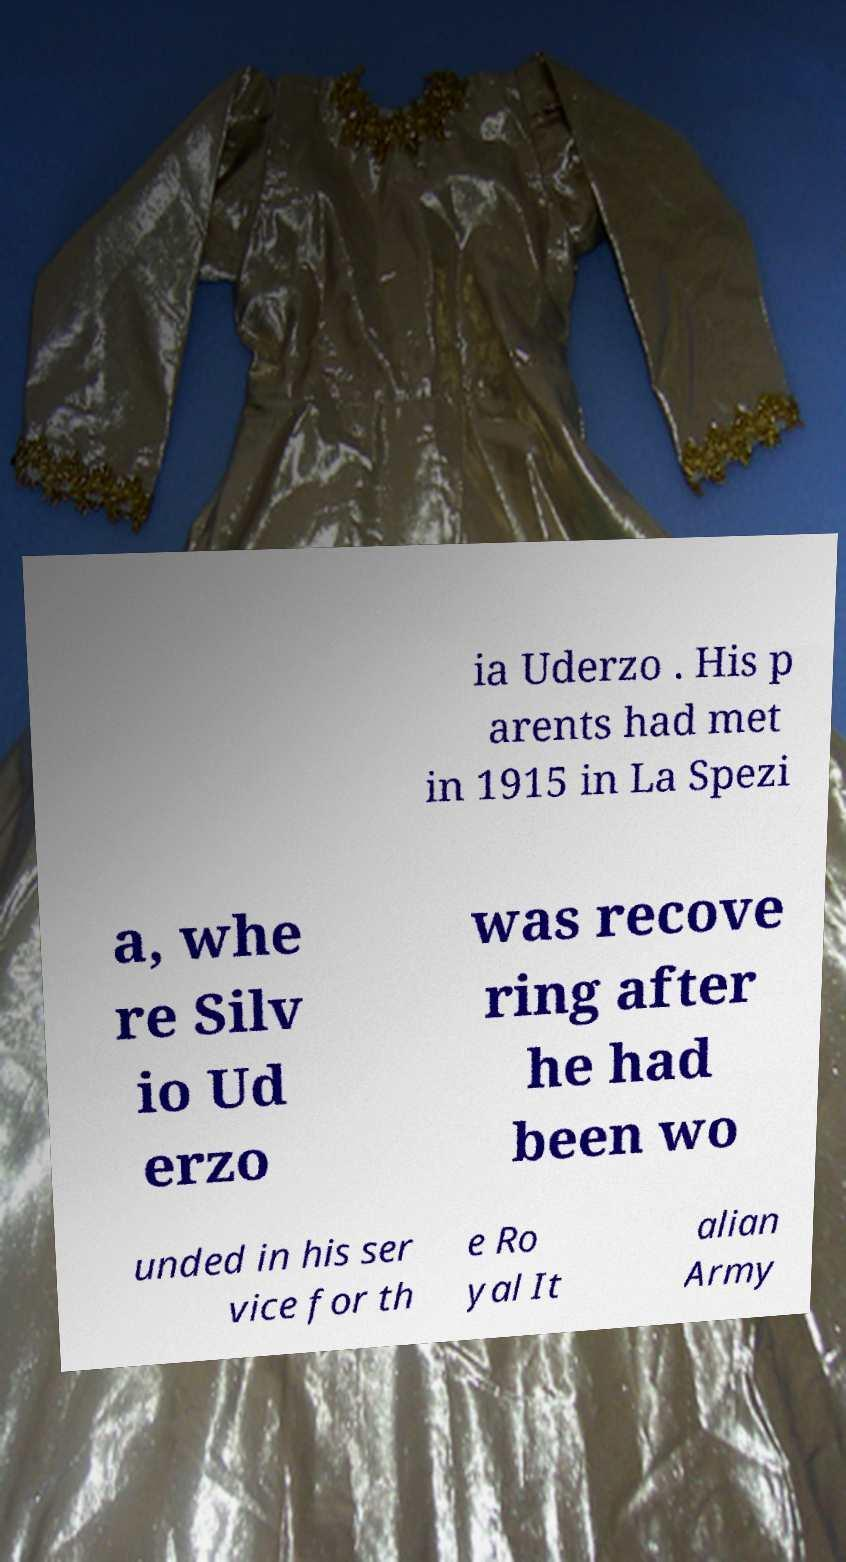Can you read and provide the text displayed in the image?This photo seems to have some interesting text. Can you extract and type it out for me? ia Uderzo . His p arents had met in 1915 in La Spezi a, whe re Silv io Ud erzo was recove ring after he had been wo unded in his ser vice for th e Ro yal It alian Army 